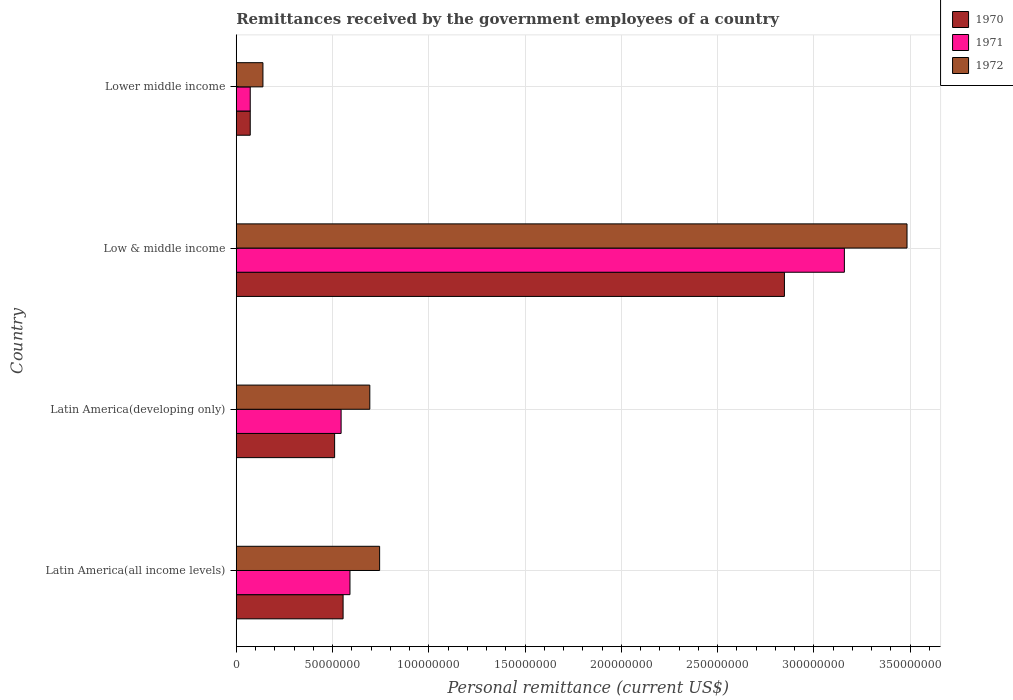How many groups of bars are there?
Ensure brevity in your answer.  4. Are the number of bars per tick equal to the number of legend labels?
Provide a succinct answer. Yes. Are the number of bars on each tick of the Y-axis equal?
Provide a succinct answer. Yes. How many bars are there on the 1st tick from the bottom?
Your answer should be compact. 3. What is the label of the 3rd group of bars from the top?
Your response must be concise. Latin America(developing only). In how many cases, is the number of bars for a given country not equal to the number of legend labels?
Make the answer very short. 0. What is the remittances received by the government employees in 1972 in Latin America(all income levels)?
Provide a succinct answer. 7.45e+07. Across all countries, what is the maximum remittances received by the government employees in 1970?
Provide a short and direct response. 2.85e+08. Across all countries, what is the minimum remittances received by the government employees in 1972?
Offer a terse response. 1.39e+07. In which country was the remittances received by the government employees in 1970 minimum?
Offer a very short reply. Lower middle income. What is the total remittances received by the government employees in 1972 in the graph?
Make the answer very short. 5.06e+08. What is the difference between the remittances received by the government employees in 1971 in Latin America(all income levels) and that in Low & middle income?
Your answer should be very brief. -2.57e+08. What is the difference between the remittances received by the government employees in 1970 in Latin America(all income levels) and the remittances received by the government employees in 1972 in Low & middle income?
Provide a short and direct response. -2.93e+08. What is the average remittances received by the government employees in 1971 per country?
Ensure brevity in your answer.  1.09e+08. What is the difference between the remittances received by the government employees in 1972 and remittances received by the government employees in 1971 in Latin America(all income levels)?
Provide a succinct answer. 1.54e+07. In how many countries, is the remittances received by the government employees in 1971 greater than 350000000 US$?
Your answer should be very brief. 0. What is the ratio of the remittances received by the government employees in 1971 in Latin America(developing only) to that in Low & middle income?
Provide a succinct answer. 0.17. What is the difference between the highest and the second highest remittances received by the government employees in 1972?
Your answer should be compact. 2.74e+08. What is the difference between the highest and the lowest remittances received by the government employees in 1972?
Your response must be concise. 3.35e+08. In how many countries, is the remittances received by the government employees in 1970 greater than the average remittances received by the government employees in 1970 taken over all countries?
Your answer should be very brief. 1. Is the sum of the remittances received by the government employees in 1970 in Latin America(all income levels) and Lower middle income greater than the maximum remittances received by the government employees in 1971 across all countries?
Keep it short and to the point. No. What does the 1st bar from the top in Lower middle income represents?
Give a very brief answer. 1972. What does the 1st bar from the bottom in Latin America(all income levels) represents?
Offer a very short reply. 1970. Are all the bars in the graph horizontal?
Your answer should be very brief. Yes. How many countries are there in the graph?
Your answer should be compact. 4. Are the values on the major ticks of X-axis written in scientific E-notation?
Your answer should be very brief. No. Does the graph contain any zero values?
Make the answer very short. No. Does the graph contain grids?
Provide a succinct answer. Yes. How many legend labels are there?
Your answer should be very brief. 3. What is the title of the graph?
Offer a very short reply. Remittances received by the government employees of a country. What is the label or title of the X-axis?
Make the answer very short. Personal remittance (current US$). What is the Personal remittance (current US$) in 1970 in Latin America(all income levels)?
Make the answer very short. 5.55e+07. What is the Personal remittance (current US$) in 1971 in Latin America(all income levels)?
Your response must be concise. 5.91e+07. What is the Personal remittance (current US$) in 1972 in Latin America(all income levels)?
Give a very brief answer. 7.45e+07. What is the Personal remittance (current US$) of 1970 in Latin America(developing only)?
Ensure brevity in your answer.  5.11e+07. What is the Personal remittance (current US$) of 1971 in Latin America(developing only)?
Your answer should be compact. 5.45e+07. What is the Personal remittance (current US$) of 1972 in Latin America(developing only)?
Give a very brief answer. 6.94e+07. What is the Personal remittance (current US$) of 1970 in Low & middle income?
Make the answer very short. 2.85e+08. What is the Personal remittance (current US$) in 1971 in Low & middle income?
Ensure brevity in your answer.  3.16e+08. What is the Personal remittance (current US$) of 1972 in Low & middle income?
Make the answer very short. 3.48e+08. What is the Personal remittance (current US$) in 1970 in Lower middle income?
Keep it short and to the point. 7.26e+06. What is the Personal remittance (current US$) in 1971 in Lower middle income?
Make the answer very short. 7.26e+06. What is the Personal remittance (current US$) in 1972 in Lower middle income?
Give a very brief answer. 1.39e+07. Across all countries, what is the maximum Personal remittance (current US$) of 1970?
Ensure brevity in your answer.  2.85e+08. Across all countries, what is the maximum Personal remittance (current US$) in 1971?
Give a very brief answer. 3.16e+08. Across all countries, what is the maximum Personal remittance (current US$) in 1972?
Make the answer very short. 3.48e+08. Across all countries, what is the minimum Personal remittance (current US$) in 1970?
Your response must be concise. 7.26e+06. Across all countries, what is the minimum Personal remittance (current US$) in 1971?
Keep it short and to the point. 7.26e+06. Across all countries, what is the minimum Personal remittance (current US$) in 1972?
Ensure brevity in your answer.  1.39e+07. What is the total Personal remittance (current US$) in 1970 in the graph?
Provide a succinct answer. 3.99e+08. What is the total Personal remittance (current US$) of 1971 in the graph?
Give a very brief answer. 4.37e+08. What is the total Personal remittance (current US$) in 1972 in the graph?
Offer a terse response. 5.06e+08. What is the difference between the Personal remittance (current US$) of 1970 in Latin America(all income levels) and that in Latin America(developing only)?
Your answer should be very brief. 4.40e+06. What is the difference between the Personal remittance (current US$) in 1971 in Latin America(all income levels) and that in Latin America(developing only)?
Make the answer very short. 4.61e+06. What is the difference between the Personal remittance (current US$) of 1972 in Latin America(all income levels) and that in Latin America(developing only)?
Your response must be concise. 5.10e+06. What is the difference between the Personal remittance (current US$) in 1970 in Latin America(all income levels) and that in Low & middle income?
Your answer should be very brief. -2.29e+08. What is the difference between the Personal remittance (current US$) in 1971 in Latin America(all income levels) and that in Low & middle income?
Give a very brief answer. -2.57e+08. What is the difference between the Personal remittance (current US$) in 1972 in Latin America(all income levels) and that in Low & middle income?
Keep it short and to the point. -2.74e+08. What is the difference between the Personal remittance (current US$) of 1970 in Latin America(all income levels) and that in Lower middle income?
Your answer should be compact. 4.82e+07. What is the difference between the Personal remittance (current US$) in 1971 in Latin America(all income levels) and that in Lower middle income?
Keep it short and to the point. 5.18e+07. What is the difference between the Personal remittance (current US$) of 1972 in Latin America(all income levels) and that in Lower middle income?
Offer a very short reply. 6.06e+07. What is the difference between the Personal remittance (current US$) in 1970 in Latin America(developing only) and that in Low & middle income?
Offer a very short reply. -2.34e+08. What is the difference between the Personal remittance (current US$) in 1971 in Latin America(developing only) and that in Low & middle income?
Give a very brief answer. -2.61e+08. What is the difference between the Personal remittance (current US$) in 1972 in Latin America(developing only) and that in Low & middle income?
Keep it short and to the point. -2.79e+08. What is the difference between the Personal remittance (current US$) in 1970 in Latin America(developing only) and that in Lower middle income?
Make the answer very short. 4.38e+07. What is the difference between the Personal remittance (current US$) of 1971 in Latin America(developing only) and that in Lower middle income?
Keep it short and to the point. 4.72e+07. What is the difference between the Personal remittance (current US$) of 1972 in Latin America(developing only) and that in Lower middle income?
Make the answer very short. 5.55e+07. What is the difference between the Personal remittance (current US$) of 1970 in Low & middle income and that in Lower middle income?
Your response must be concise. 2.77e+08. What is the difference between the Personal remittance (current US$) of 1971 in Low & middle income and that in Lower middle income?
Provide a succinct answer. 3.09e+08. What is the difference between the Personal remittance (current US$) in 1972 in Low & middle income and that in Lower middle income?
Your answer should be very brief. 3.35e+08. What is the difference between the Personal remittance (current US$) of 1970 in Latin America(all income levels) and the Personal remittance (current US$) of 1971 in Latin America(developing only)?
Make the answer very short. 1.03e+06. What is the difference between the Personal remittance (current US$) in 1970 in Latin America(all income levels) and the Personal remittance (current US$) in 1972 in Latin America(developing only)?
Provide a short and direct response. -1.39e+07. What is the difference between the Personal remittance (current US$) of 1971 in Latin America(all income levels) and the Personal remittance (current US$) of 1972 in Latin America(developing only)?
Your answer should be compact. -1.03e+07. What is the difference between the Personal remittance (current US$) of 1970 in Latin America(all income levels) and the Personal remittance (current US$) of 1971 in Low & middle income?
Offer a terse response. -2.60e+08. What is the difference between the Personal remittance (current US$) in 1970 in Latin America(all income levels) and the Personal remittance (current US$) in 1972 in Low & middle income?
Ensure brevity in your answer.  -2.93e+08. What is the difference between the Personal remittance (current US$) in 1971 in Latin America(all income levels) and the Personal remittance (current US$) in 1972 in Low & middle income?
Give a very brief answer. -2.89e+08. What is the difference between the Personal remittance (current US$) in 1970 in Latin America(all income levels) and the Personal remittance (current US$) in 1971 in Lower middle income?
Ensure brevity in your answer.  4.82e+07. What is the difference between the Personal remittance (current US$) of 1970 in Latin America(all income levels) and the Personal remittance (current US$) of 1972 in Lower middle income?
Your answer should be very brief. 4.16e+07. What is the difference between the Personal remittance (current US$) of 1971 in Latin America(all income levels) and the Personal remittance (current US$) of 1972 in Lower middle income?
Your answer should be compact. 4.52e+07. What is the difference between the Personal remittance (current US$) of 1970 in Latin America(developing only) and the Personal remittance (current US$) of 1971 in Low & middle income?
Your answer should be compact. -2.65e+08. What is the difference between the Personal remittance (current US$) of 1970 in Latin America(developing only) and the Personal remittance (current US$) of 1972 in Low & middle income?
Offer a very short reply. -2.97e+08. What is the difference between the Personal remittance (current US$) in 1971 in Latin America(developing only) and the Personal remittance (current US$) in 1972 in Low & middle income?
Ensure brevity in your answer.  -2.94e+08. What is the difference between the Personal remittance (current US$) in 1970 in Latin America(developing only) and the Personal remittance (current US$) in 1971 in Lower middle income?
Your answer should be very brief. 4.38e+07. What is the difference between the Personal remittance (current US$) in 1970 in Latin America(developing only) and the Personal remittance (current US$) in 1972 in Lower middle income?
Your response must be concise. 3.72e+07. What is the difference between the Personal remittance (current US$) in 1971 in Latin America(developing only) and the Personal remittance (current US$) in 1972 in Lower middle income?
Provide a succinct answer. 4.06e+07. What is the difference between the Personal remittance (current US$) in 1970 in Low & middle income and the Personal remittance (current US$) in 1971 in Lower middle income?
Make the answer very short. 2.77e+08. What is the difference between the Personal remittance (current US$) in 1970 in Low & middle income and the Personal remittance (current US$) in 1972 in Lower middle income?
Keep it short and to the point. 2.71e+08. What is the difference between the Personal remittance (current US$) of 1971 in Low & middle income and the Personal remittance (current US$) of 1972 in Lower middle income?
Your answer should be very brief. 3.02e+08. What is the average Personal remittance (current US$) of 1970 per country?
Offer a terse response. 9.97e+07. What is the average Personal remittance (current US$) in 1971 per country?
Offer a very short reply. 1.09e+08. What is the average Personal remittance (current US$) of 1972 per country?
Provide a short and direct response. 1.27e+08. What is the difference between the Personal remittance (current US$) of 1970 and Personal remittance (current US$) of 1971 in Latin America(all income levels)?
Provide a short and direct response. -3.57e+06. What is the difference between the Personal remittance (current US$) in 1970 and Personal remittance (current US$) in 1972 in Latin America(all income levels)?
Give a very brief answer. -1.90e+07. What is the difference between the Personal remittance (current US$) of 1971 and Personal remittance (current US$) of 1972 in Latin America(all income levels)?
Your answer should be compact. -1.54e+07. What is the difference between the Personal remittance (current US$) of 1970 and Personal remittance (current US$) of 1971 in Latin America(developing only)?
Provide a succinct answer. -3.37e+06. What is the difference between the Personal remittance (current US$) in 1970 and Personal remittance (current US$) in 1972 in Latin America(developing only)?
Provide a short and direct response. -1.83e+07. What is the difference between the Personal remittance (current US$) in 1971 and Personal remittance (current US$) in 1972 in Latin America(developing only)?
Make the answer very short. -1.49e+07. What is the difference between the Personal remittance (current US$) of 1970 and Personal remittance (current US$) of 1971 in Low & middle income?
Offer a very short reply. -3.11e+07. What is the difference between the Personal remittance (current US$) in 1970 and Personal remittance (current US$) in 1972 in Low & middle income?
Offer a very short reply. -6.37e+07. What is the difference between the Personal remittance (current US$) in 1971 and Personal remittance (current US$) in 1972 in Low & middle income?
Your answer should be very brief. -3.25e+07. What is the difference between the Personal remittance (current US$) of 1970 and Personal remittance (current US$) of 1971 in Lower middle income?
Offer a terse response. 0. What is the difference between the Personal remittance (current US$) of 1970 and Personal remittance (current US$) of 1972 in Lower middle income?
Offer a terse response. -6.60e+06. What is the difference between the Personal remittance (current US$) of 1971 and Personal remittance (current US$) of 1972 in Lower middle income?
Offer a terse response. -6.60e+06. What is the ratio of the Personal remittance (current US$) of 1970 in Latin America(all income levels) to that in Latin America(developing only)?
Offer a very short reply. 1.09. What is the ratio of the Personal remittance (current US$) of 1971 in Latin America(all income levels) to that in Latin America(developing only)?
Your answer should be compact. 1.08. What is the ratio of the Personal remittance (current US$) in 1972 in Latin America(all income levels) to that in Latin America(developing only)?
Ensure brevity in your answer.  1.07. What is the ratio of the Personal remittance (current US$) of 1970 in Latin America(all income levels) to that in Low & middle income?
Ensure brevity in your answer.  0.19. What is the ratio of the Personal remittance (current US$) in 1971 in Latin America(all income levels) to that in Low & middle income?
Provide a short and direct response. 0.19. What is the ratio of the Personal remittance (current US$) in 1972 in Latin America(all income levels) to that in Low & middle income?
Give a very brief answer. 0.21. What is the ratio of the Personal remittance (current US$) of 1970 in Latin America(all income levels) to that in Lower middle income?
Make the answer very short. 7.64. What is the ratio of the Personal remittance (current US$) in 1971 in Latin America(all income levels) to that in Lower middle income?
Ensure brevity in your answer.  8.14. What is the ratio of the Personal remittance (current US$) in 1972 in Latin America(all income levels) to that in Lower middle income?
Offer a very short reply. 5.37. What is the ratio of the Personal remittance (current US$) of 1970 in Latin America(developing only) to that in Low & middle income?
Give a very brief answer. 0.18. What is the ratio of the Personal remittance (current US$) of 1971 in Latin America(developing only) to that in Low & middle income?
Provide a succinct answer. 0.17. What is the ratio of the Personal remittance (current US$) of 1972 in Latin America(developing only) to that in Low & middle income?
Provide a succinct answer. 0.2. What is the ratio of the Personal remittance (current US$) in 1970 in Latin America(developing only) to that in Lower middle income?
Ensure brevity in your answer.  7.04. What is the ratio of the Personal remittance (current US$) of 1971 in Latin America(developing only) to that in Lower middle income?
Give a very brief answer. 7.5. What is the ratio of the Personal remittance (current US$) of 1972 in Latin America(developing only) to that in Lower middle income?
Your answer should be very brief. 5.01. What is the ratio of the Personal remittance (current US$) in 1970 in Low & middle income to that in Lower middle income?
Ensure brevity in your answer.  39.22. What is the ratio of the Personal remittance (current US$) in 1971 in Low & middle income to that in Lower middle income?
Keep it short and to the point. 43.51. What is the ratio of the Personal remittance (current US$) in 1972 in Low & middle income to that in Lower middle income?
Keep it short and to the point. 25.14. What is the difference between the highest and the second highest Personal remittance (current US$) of 1970?
Offer a very short reply. 2.29e+08. What is the difference between the highest and the second highest Personal remittance (current US$) of 1971?
Provide a short and direct response. 2.57e+08. What is the difference between the highest and the second highest Personal remittance (current US$) in 1972?
Provide a succinct answer. 2.74e+08. What is the difference between the highest and the lowest Personal remittance (current US$) of 1970?
Offer a terse response. 2.77e+08. What is the difference between the highest and the lowest Personal remittance (current US$) of 1971?
Provide a short and direct response. 3.09e+08. What is the difference between the highest and the lowest Personal remittance (current US$) in 1972?
Ensure brevity in your answer.  3.35e+08. 